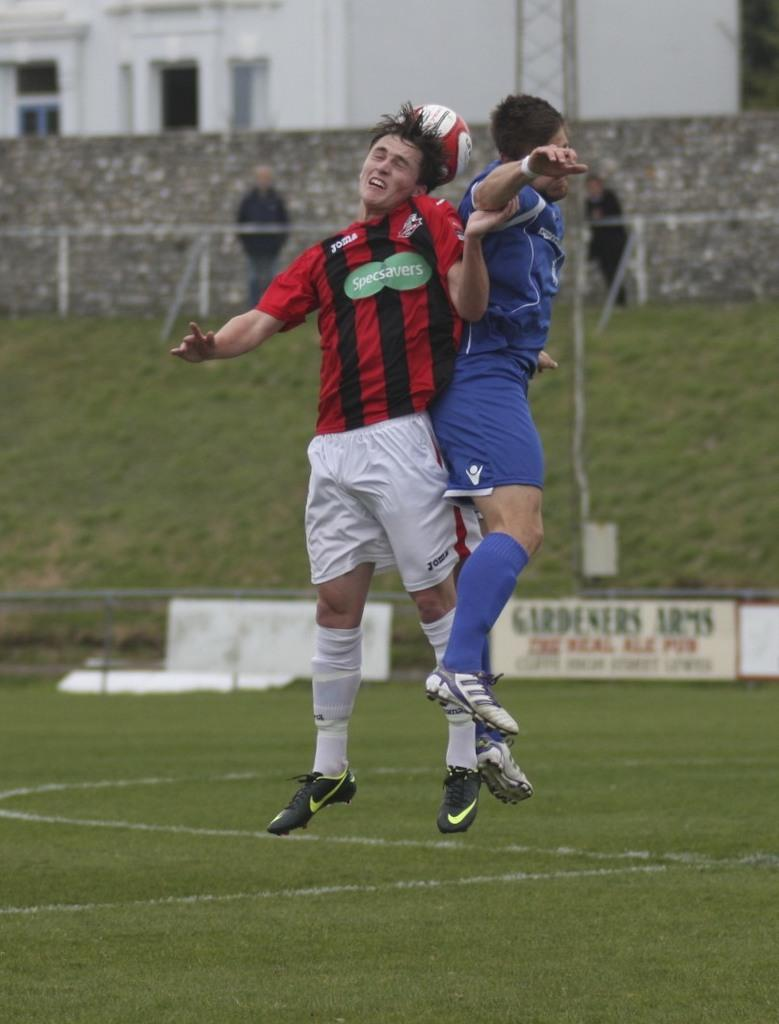What is happening with the 2 men in the image? The 2 men are in the air in the image. What object can be seen in the image besides the men? There is a ball in the image. What type of surface is visible in the image? There is grass visible in the image. Can you describe the background of the image? In the background of the image, there are 2 persons standing, a wall, and a building. What type of bears can be seen interacting with the men in the image? There are no bears present in the image; it features 2 men in the air and a ball. What is the relation between the 2 men in the image? The provided facts do not give any information about the relationship between the 2 men in the image. 